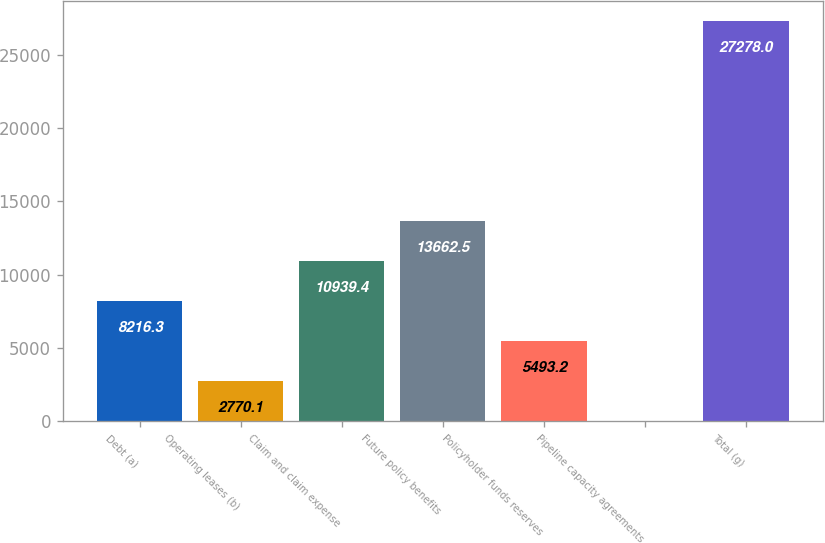Convert chart to OTSL. <chart><loc_0><loc_0><loc_500><loc_500><bar_chart><fcel>Debt (a)<fcel>Operating leases (b)<fcel>Claim and claim expense<fcel>Future policy benefits<fcel>Policyholder funds reserves<fcel>Pipeline capacity agreements<fcel>Total (g)<nl><fcel>8216.3<fcel>2770.1<fcel>10939.4<fcel>13662.5<fcel>5493.2<fcel>47<fcel>27278<nl></chart> 